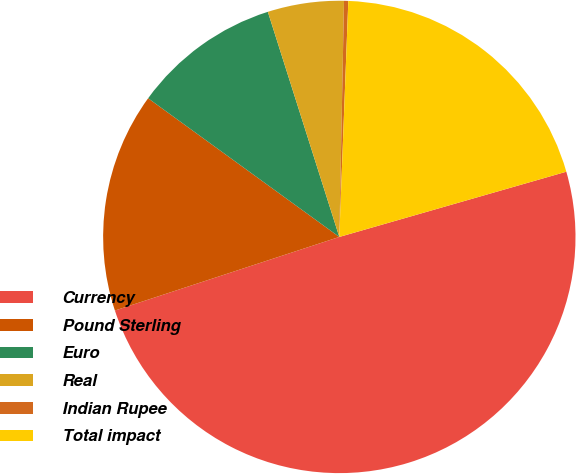<chart> <loc_0><loc_0><loc_500><loc_500><pie_chart><fcel>Currency<fcel>Pound Sterling<fcel>Euro<fcel>Real<fcel>Indian Rupee<fcel>Total impact<nl><fcel>49.41%<fcel>15.03%<fcel>10.12%<fcel>5.21%<fcel>0.29%<fcel>19.94%<nl></chart> 